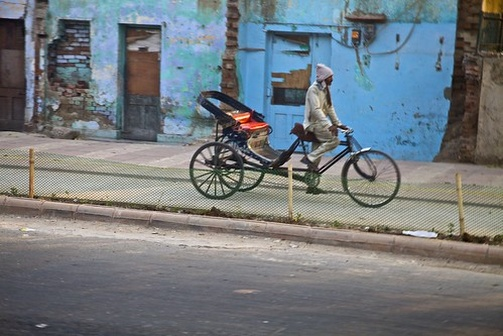Can you create a short story inspired by this image? Marcos pedaled down the familiar streets of his neighborhood, his red tricycle gliding smoothly along the pavement. Every day for the past five years, he had taken this route, delivering goods to local stores and houses. Today was no different, but as he passed the old blue building, he noticed something new—a small boy sitting on the steps, holding a stray kitten. Marcos stopped and smiled at the boy, 'Hello there! That kitty looks like it needs a friend.' The boy looked up with hopeful eyes, 'Do you think so?' Marcos nodded, 'Absolutely. Just like my tricycle here, friendship turns ordinary into extraordinary.' The boy grinned, and with a new sense of purpose, continued to pet the kitten, while Marcos resumed his journey, knowing he had made a small difference that day. 